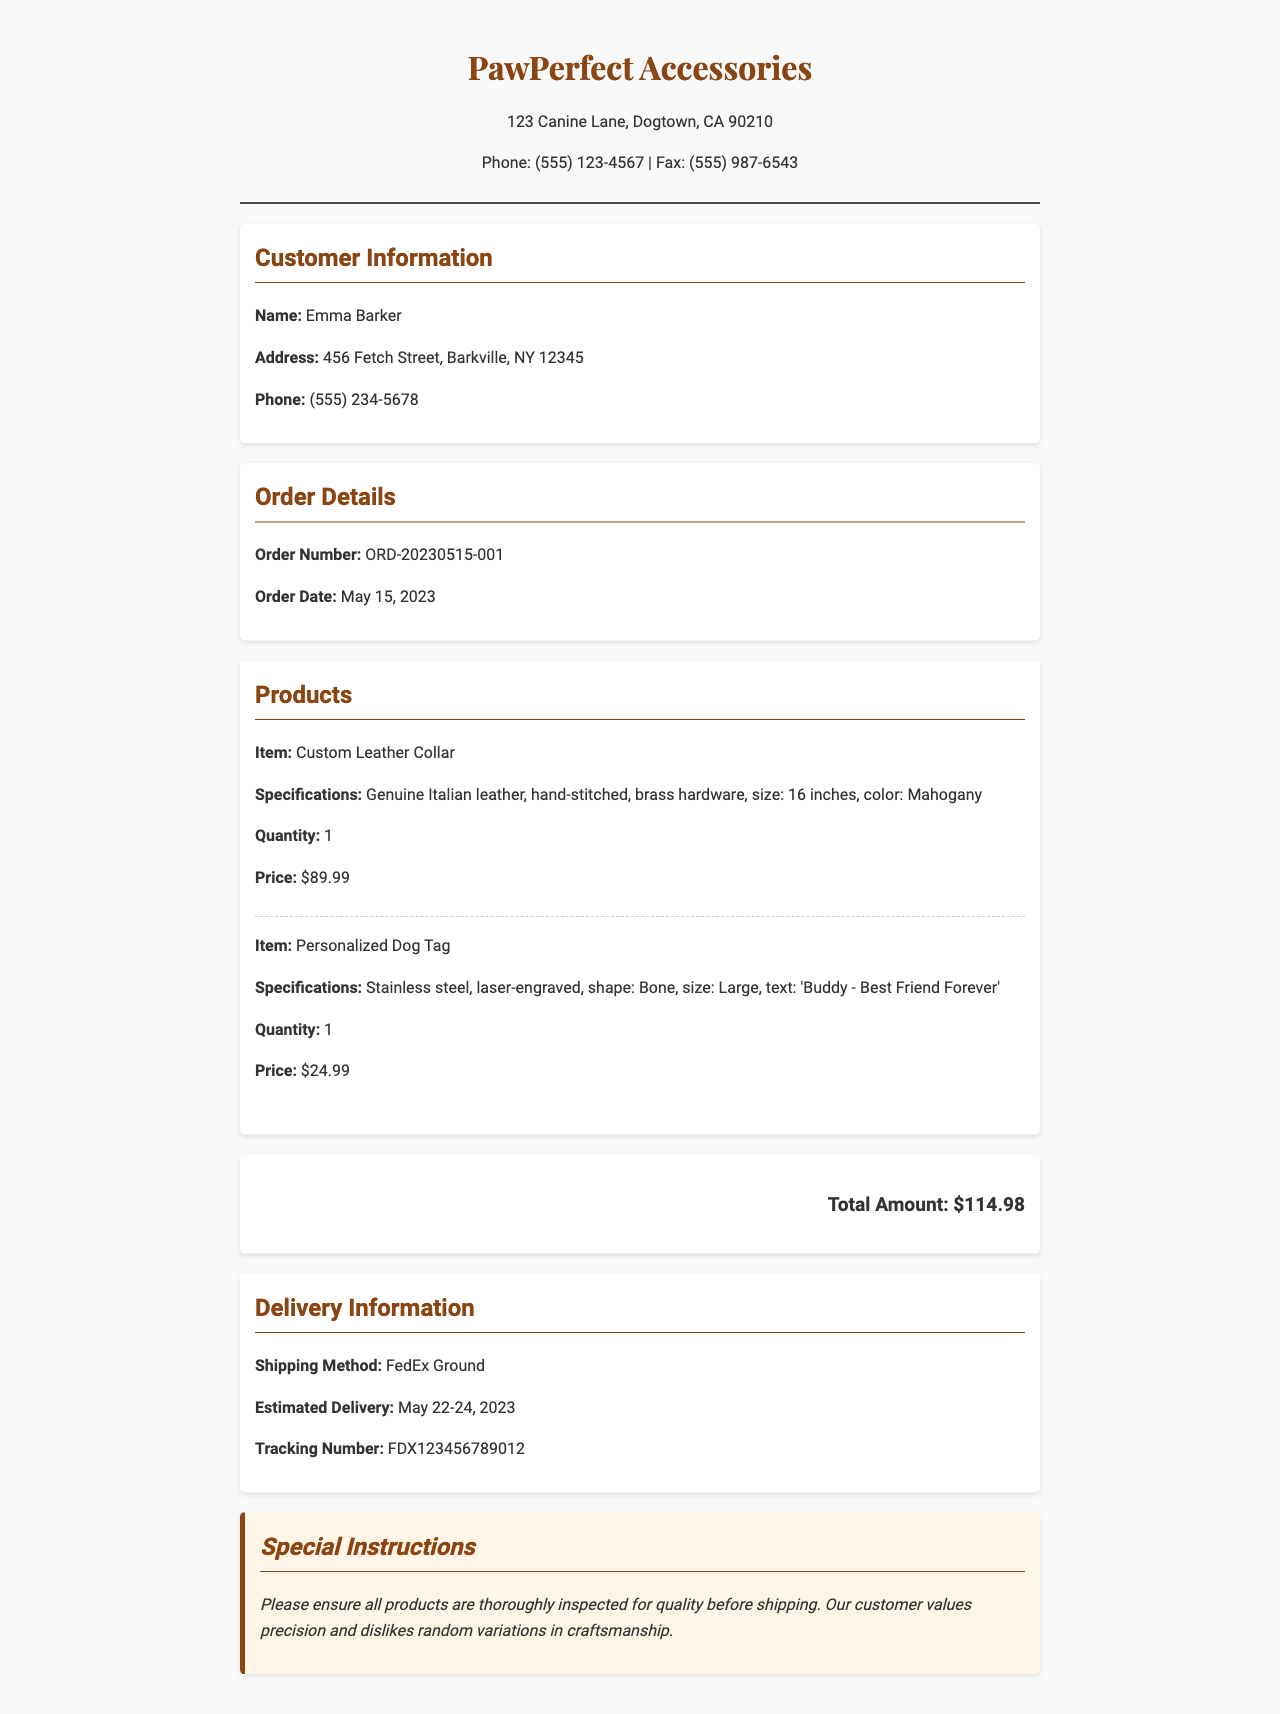What is the name of the customer? The customer name is provided in the customer information section of the document.
Answer: Emma Barker What is the order number? The order number is a unique identifier for the order mentioned in the order details section of the document.
Answer: ORD-20230515-001 What is the total amount of the order? The total amount is calculated by summing the prices of all items listed in the product list section.
Answer: $114.98 What is the estimated delivery date? The estimated delivery date is given in the delivery information section of the document.
Answer: May 22-24, 2023 What is the shipping method? The shipping method is specified in the delivery information section of the document.
Answer: FedEx Ground How many custom leather collars were ordered? The quantity ordered is stated in the product list for the custom leather collar.
Answer: 1 What color is the custom leather collar? The color of the custom leather collar is specified in the product list section of the document.
Answer: Mahogany What special instructions were provided? The special instructions that highlight the customer's preferences are included in the special instructions section.
Answer: Please ensure all products are thoroughly inspected for quality before shipping What type of product is the 'Bone' shaped tag? The type of product is identified in the product list section of the document.
Answer: Personalized Dog Tag 